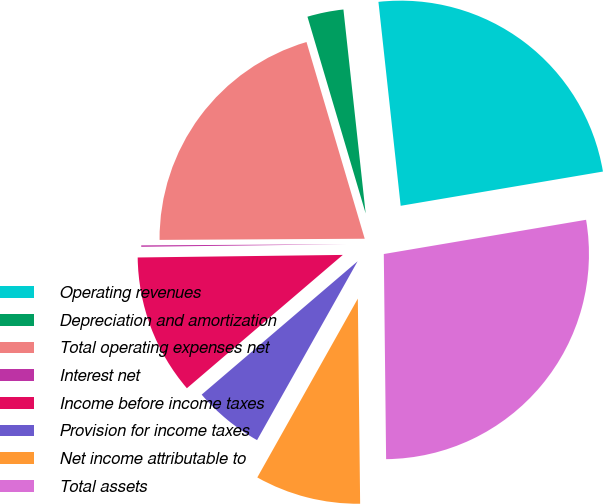Convert chart. <chart><loc_0><loc_0><loc_500><loc_500><pie_chart><fcel>Operating revenues<fcel>Depreciation and amortization<fcel>Total operating expenses net<fcel>Interest net<fcel>Income before income taxes<fcel>Provision for income taxes<fcel>Net income attributable to<fcel>Total assets<nl><fcel>24.06%<fcel>2.85%<fcel>20.51%<fcel>0.11%<fcel>11.06%<fcel>5.59%<fcel>8.33%<fcel>27.49%<nl></chart> 